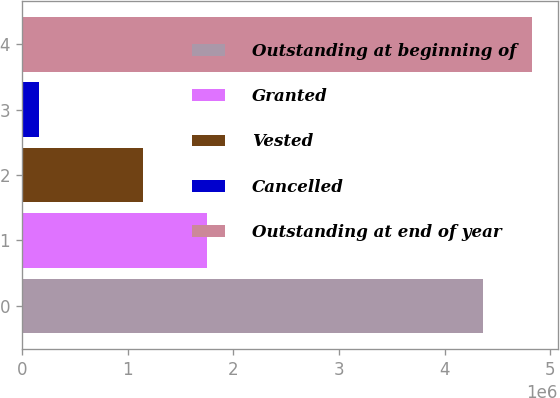<chart> <loc_0><loc_0><loc_500><loc_500><bar_chart><fcel>Outstanding at beginning of<fcel>Granted<fcel>Vested<fcel>Cancelled<fcel>Outstanding at end of year<nl><fcel>4.36578e+06<fcel>1.74787e+06<fcel>1.14906e+06<fcel>166675<fcel>4.82891e+06<nl></chart> 